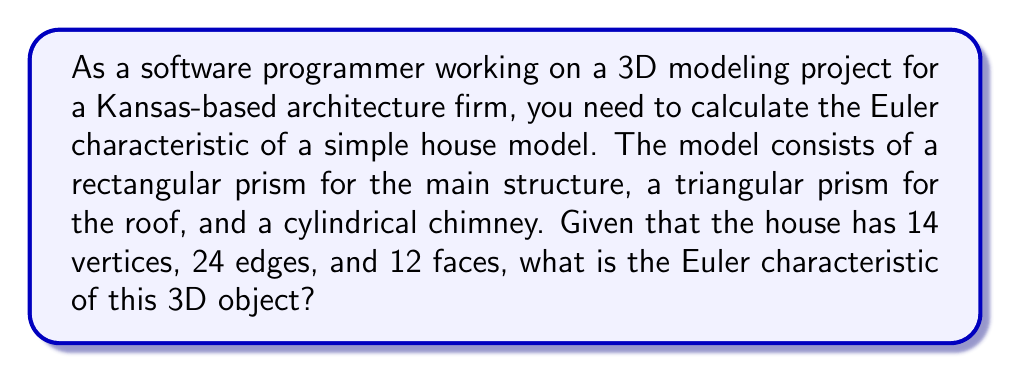Provide a solution to this math problem. To solve this problem, we'll use the Euler characteristic formula for 3D objects:

$$ \chi = V - E + F $$

Where:
$\chi$ (chi) is the Euler characteristic
$V$ is the number of vertices
$E$ is the number of edges
$F$ is the number of faces

Given:
$V = 14$ (vertices)
$E = 24$ (edges)
$F = 12$ (faces)

Let's substitute these values into the formula:

$$ \chi = 14 - 24 + 12 $$

Now, let's calculate:

$$ \chi = 14 - 24 + 12 = 2 $$

The Euler characteristic of this 3D house model is 2.

It's worth noting that for any convex polyhedron (which includes combinations of simple 3D shapes like in this house model), the Euler characteristic will always be 2. This is known as Euler's polyhedron formula.

In computer graphics, calculating the Euler characteristic can be useful for:
1. Verifying the topological correctness of 3D models
2. Detecting errors in mesh generation
3. Analyzing the complexity of 3D objects

For a software programmer working with 3D models, understanding and implementing this calculation can be valuable for model validation and optimization tasks.
Answer: $$ \chi = 2 $$ 